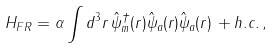<formula> <loc_0><loc_0><loc_500><loc_500>H _ { F R } = \alpha \int d ^ { 3 } r \, \hat { \psi } _ { m } ^ { \dagger } ( { r } ) \hat { \psi } _ { a } ( { r } ) \hat { \psi } _ { a } ( { r } ) \, + h . c . \, ,</formula> 